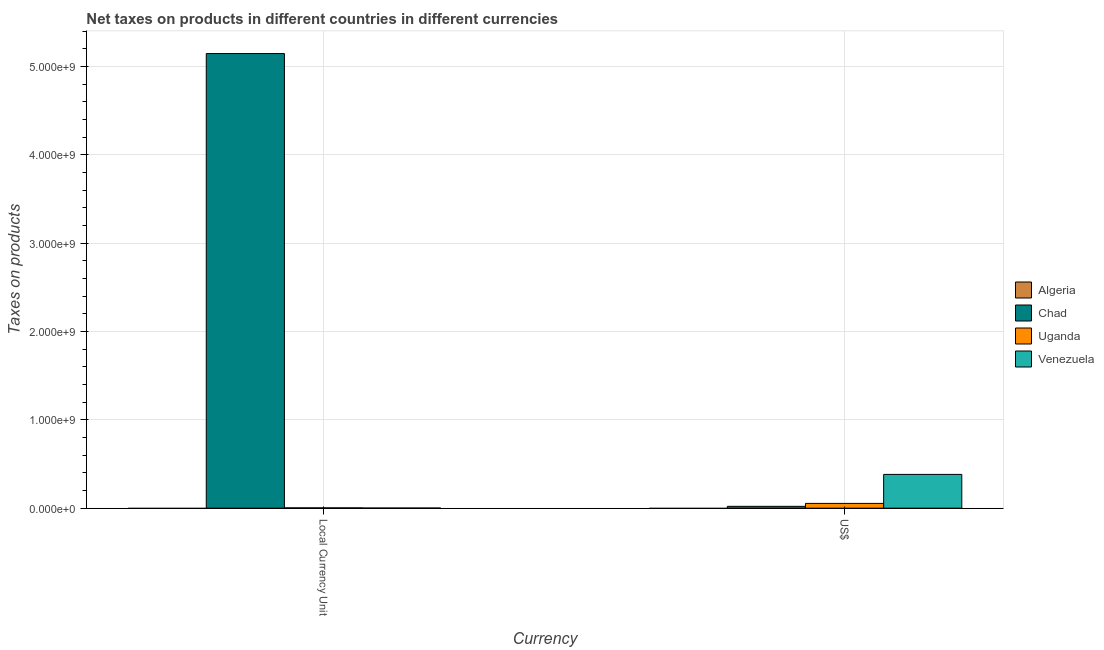How many different coloured bars are there?
Provide a succinct answer. 3. How many groups of bars are there?
Your answer should be very brief. 2. Are the number of bars per tick equal to the number of legend labels?
Provide a short and direct response. No. What is the label of the 1st group of bars from the left?
Provide a short and direct response. Local Currency Unit. What is the net taxes in us$ in Uganda?
Keep it short and to the point. 5.43e+07. Across all countries, what is the maximum net taxes in us$?
Offer a terse response. 3.83e+08. Across all countries, what is the minimum net taxes in constant 2005 us$?
Ensure brevity in your answer.  0. In which country was the net taxes in constant 2005 us$ maximum?
Your response must be concise. Chad. What is the total net taxes in constant 2005 us$ in the graph?
Offer a terse response. 5.15e+09. What is the difference between the net taxes in us$ in Uganda and that in Venezuela?
Provide a succinct answer. -3.28e+08. What is the difference between the net taxes in constant 2005 us$ in Algeria and the net taxes in us$ in Chad?
Provide a succinct answer. -2.10e+07. What is the average net taxes in us$ per country?
Keep it short and to the point. 1.15e+08. What is the difference between the net taxes in us$ and net taxes in constant 2005 us$ in Chad?
Provide a succinct answer. -5.13e+09. What is the ratio of the net taxes in constant 2005 us$ in Venezuela to that in Chad?
Provide a short and direct response. 0. In how many countries, is the net taxes in us$ greater than the average net taxes in us$ taken over all countries?
Provide a succinct answer. 1. How many bars are there?
Ensure brevity in your answer.  6. How many countries are there in the graph?
Your response must be concise. 4. What is the difference between two consecutive major ticks on the Y-axis?
Give a very brief answer. 1.00e+09. Does the graph contain grids?
Ensure brevity in your answer.  Yes. Where does the legend appear in the graph?
Make the answer very short. Center right. What is the title of the graph?
Your answer should be very brief. Net taxes on products in different countries in different currencies. Does "Syrian Arab Republic" appear as one of the legend labels in the graph?
Provide a short and direct response. No. What is the label or title of the X-axis?
Offer a terse response. Currency. What is the label or title of the Y-axis?
Your response must be concise. Taxes on products. What is the Taxes on products in Chad in Local Currency Unit?
Your answer should be compact. 5.15e+09. What is the Taxes on products in Uganda in Local Currency Unit?
Offer a terse response. 3.88e+06. What is the Taxes on products in Venezuela in Local Currency Unit?
Offer a very short reply. 1.70e+06. What is the Taxes on products in Chad in US$?
Offer a terse response. 2.10e+07. What is the Taxes on products of Uganda in US$?
Offer a terse response. 5.43e+07. What is the Taxes on products in Venezuela in US$?
Your answer should be compact. 3.83e+08. Across all Currency, what is the maximum Taxes on products of Chad?
Provide a short and direct response. 5.15e+09. Across all Currency, what is the maximum Taxes on products of Uganda?
Ensure brevity in your answer.  5.43e+07. Across all Currency, what is the maximum Taxes on products of Venezuela?
Make the answer very short. 3.83e+08. Across all Currency, what is the minimum Taxes on products of Chad?
Keep it short and to the point. 2.10e+07. Across all Currency, what is the minimum Taxes on products in Uganda?
Give a very brief answer. 3.88e+06. Across all Currency, what is the minimum Taxes on products of Venezuela?
Your answer should be compact. 1.70e+06. What is the total Taxes on products of Algeria in the graph?
Keep it short and to the point. 0. What is the total Taxes on products of Chad in the graph?
Keep it short and to the point. 5.17e+09. What is the total Taxes on products in Uganda in the graph?
Offer a very short reply. 5.82e+07. What is the total Taxes on products of Venezuela in the graph?
Give a very brief answer. 3.84e+08. What is the difference between the Taxes on products in Chad in Local Currency Unit and that in US$?
Make the answer very short. 5.13e+09. What is the difference between the Taxes on products in Uganda in Local Currency Unit and that in US$?
Ensure brevity in your answer.  -5.04e+07. What is the difference between the Taxes on products in Venezuela in Local Currency Unit and that in US$?
Provide a short and direct response. -3.81e+08. What is the difference between the Taxes on products in Chad in Local Currency Unit and the Taxes on products in Uganda in US$?
Offer a terse response. 5.09e+09. What is the difference between the Taxes on products in Chad in Local Currency Unit and the Taxes on products in Venezuela in US$?
Your answer should be very brief. 4.77e+09. What is the difference between the Taxes on products of Uganda in Local Currency Unit and the Taxes on products of Venezuela in US$?
Offer a terse response. -3.79e+08. What is the average Taxes on products of Algeria per Currency?
Keep it short and to the point. 0. What is the average Taxes on products of Chad per Currency?
Provide a succinct answer. 2.58e+09. What is the average Taxes on products of Uganda per Currency?
Provide a short and direct response. 2.91e+07. What is the average Taxes on products in Venezuela per Currency?
Give a very brief answer. 1.92e+08. What is the difference between the Taxes on products in Chad and Taxes on products in Uganda in Local Currency Unit?
Give a very brief answer. 5.14e+09. What is the difference between the Taxes on products in Chad and Taxes on products in Venezuela in Local Currency Unit?
Your answer should be compact. 5.15e+09. What is the difference between the Taxes on products in Uganda and Taxes on products in Venezuela in Local Currency Unit?
Offer a very short reply. 2.18e+06. What is the difference between the Taxes on products of Chad and Taxes on products of Uganda in US$?
Provide a short and direct response. -3.33e+07. What is the difference between the Taxes on products in Chad and Taxes on products in Venezuela in US$?
Offer a terse response. -3.62e+08. What is the difference between the Taxes on products of Uganda and Taxes on products of Venezuela in US$?
Your response must be concise. -3.28e+08. What is the ratio of the Taxes on products in Chad in Local Currency Unit to that in US$?
Provide a short and direct response. 245.06. What is the ratio of the Taxes on products in Uganda in Local Currency Unit to that in US$?
Provide a succinct answer. 0.07. What is the ratio of the Taxes on products of Venezuela in Local Currency Unit to that in US$?
Offer a very short reply. 0. What is the difference between the highest and the second highest Taxes on products of Chad?
Keep it short and to the point. 5.13e+09. What is the difference between the highest and the second highest Taxes on products of Uganda?
Your answer should be compact. 5.04e+07. What is the difference between the highest and the second highest Taxes on products of Venezuela?
Offer a very short reply. 3.81e+08. What is the difference between the highest and the lowest Taxes on products in Chad?
Your answer should be very brief. 5.13e+09. What is the difference between the highest and the lowest Taxes on products in Uganda?
Keep it short and to the point. 5.04e+07. What is the difference between the highest and the lowest Taxes on products of Venezuela?
Your response must be concise. 3.81e+08. 